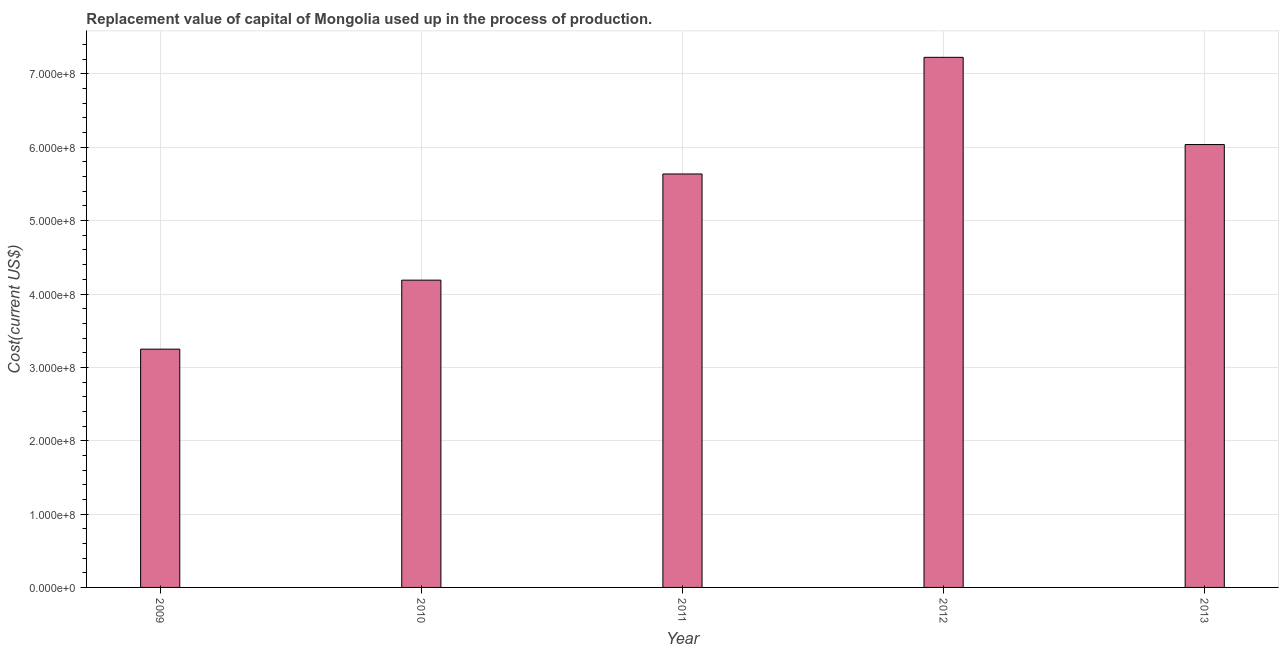What is the title of the graph?
Your answer should be compact. Replacement value of capital of Mongolia used up in the process of production. What is the label or title of the X-axis?
Offer a very short reply. Year. What is the label or title of the Y-axis?
Make the answer very short. Cost(current US$). What is the consumption of fixed capital in 2011?
Provide a succinct answer. 5.64e+08. Across all years, what is the maximum consumption of fixed capital?
Provide a succinct answer. 7.23e+08. Across all years, what is the minimum consumption of fixed capital?
Keep it short and to the point. 3.25e+08. In which year was the consumption of fixed capital maximum?
Provide a succinct answer. 2012. What is the sum of the consumption of fixed capital?
Offer a terse response. 2.63e+09. What is the difference between the consumption of fixed capital in 2009 and 2011?
Your answer should be compact. -2.39e+08. What is the average consumption of fixed capital per year?
Keep it short and to the point. 5.27e+08. What is the median consumption of fixed capital?
Your answer should be compact. 5.64e+08. Do a majority of the years between 2011 and 2013 (inclusive) have consumption of fixed capital greater than 380000000 US$?
Provide a short and direct response. Yes. What is the ratio of the consumption of fixed capital in 2009 to that in 2010?
Your answer should be compact. 0.78. Is the consumption of fixed capital in 2009 less than that in 2010?
Provide a short and direct response. Yes. Is the difference between the consumption of fixed capital in 2012 and 2013 greater than the difference between any two years?
Ensure brevity in your answer.  No. What is the difference between the highest and the second highest consumption of fixed capital?
Provide a short and direct response. 1.19e+08. What is the difference between the highest and the lowest consumption of fixed capital?
Keep it short and to the point. 3.98e+08. How many bars are there?
Your answer should be very brief. 5. Are all the bars in the graph horizontal?
Provide a short and direct response. No. How many years are there in the graph?
Your answer should be very brief. 5. What is the difference between two consecutive major ticks on the Y-axis?
Provide a succinct answer. 1.00e+08. What is the Cost(current US$) in 2009?
Your answer should be very brief. 3.25e+08. What is the Cost(current US$) of 2010?
Provide a short and direct response. 4.19e+08. What is the Cost(current US$) in 2011?
Give a very brief answer. 5.64e+08. What is the Cost(current US$) in 2012?
Your response must be concise. 7.23e+08. What is the Cost(current US$) of 2013?
Provide a succinct answer. 6.04e+08. What is the difference between the Cost(current US$) in 2009 and 2010?
Your response must be concise. -9.41e+07. What is the difference between the Cost(current US$) in 2009 and 2011?
Provide a succinct answer. -2.39e+08. What is the difference between the Cost(current US$) in 2009 and 2012?
Your answer should be very brief. -3.98e+08. What is the difference between the Cost(current US$) in 2009 and 2013?
Your response must be concise. -2.79e+08. What is the difference between the Cost(current US$) in 2010 and 2011?
Offer a terse response. -1.45e+08. What is the difference between the Cost(current US$) in 2010 and 2012?
Offer a very short reply. -3.04e+08. What is the difference between the Cost(current US$) in 2010 and 2013?
Give a very brief answer. -1.85e+08. What is the difference between the Cost(current US$) in 2011 and 2012?
Ensure brevity in your answer.  -1.59e+08. What is the difference between the Cost(current US$) in 2011 and 2013?
Provide a short and direct response. -4.01e+07. What is the difference between the Cost(current US$) in 2012 and 2013?
Offer a very short reply. 1.19e+08. What is the ratio of the Cost(current US$) in 2009 to that in 2010?
Offer a very short reply. 0.78. What is the ratio of the Cost(current US$) in 2009 to that in 2011?
Give a very brief answer. 0.58. What is the ratio of the Cost(current US$) in 2009 to that in 2012?
Your response must be concise. 0.45. What is the ratio of the Cost(current US$) in 2009 to that in 2013?
Your response must be concise. 0.54. What is the ratio of the Cost(current US$) in 2010 to that in 2011?
Your answer should be very brief. 0.74. What is the ratio of the Cost(current US$) in 2010 to that in 2012?
Your response must be concise. 0.58. What is the ratio of the Cost(current US$) in 2010 to that in 2013?
Offer a very short reply. 0.69. What is the ratio of the Cost(current US$) in 2011 to that in 2012?
Provide a short and direct response. 0.78. What is the ratio of the Cost(current US$) in 2011 to that in 2013?
Your response must be concise. 0.93. What is the ratio of the Cost(current US$) in 2012 to that in 2013?
Keep it short and to the point. 1.2. 